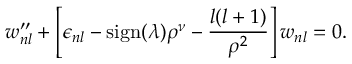<formula> <loc_0><loc_0><loc_500><loc_500>w _ { n l } ^ { \prime \prime } + \left [ \epsilon _ { n l } - s i g n ( \lambda ) \rho ^ { \nu } - \frac { l ( l + 1 ) } { \rho ^ { 2 } } \right ] w _ { n l } = 0 .</formula> 